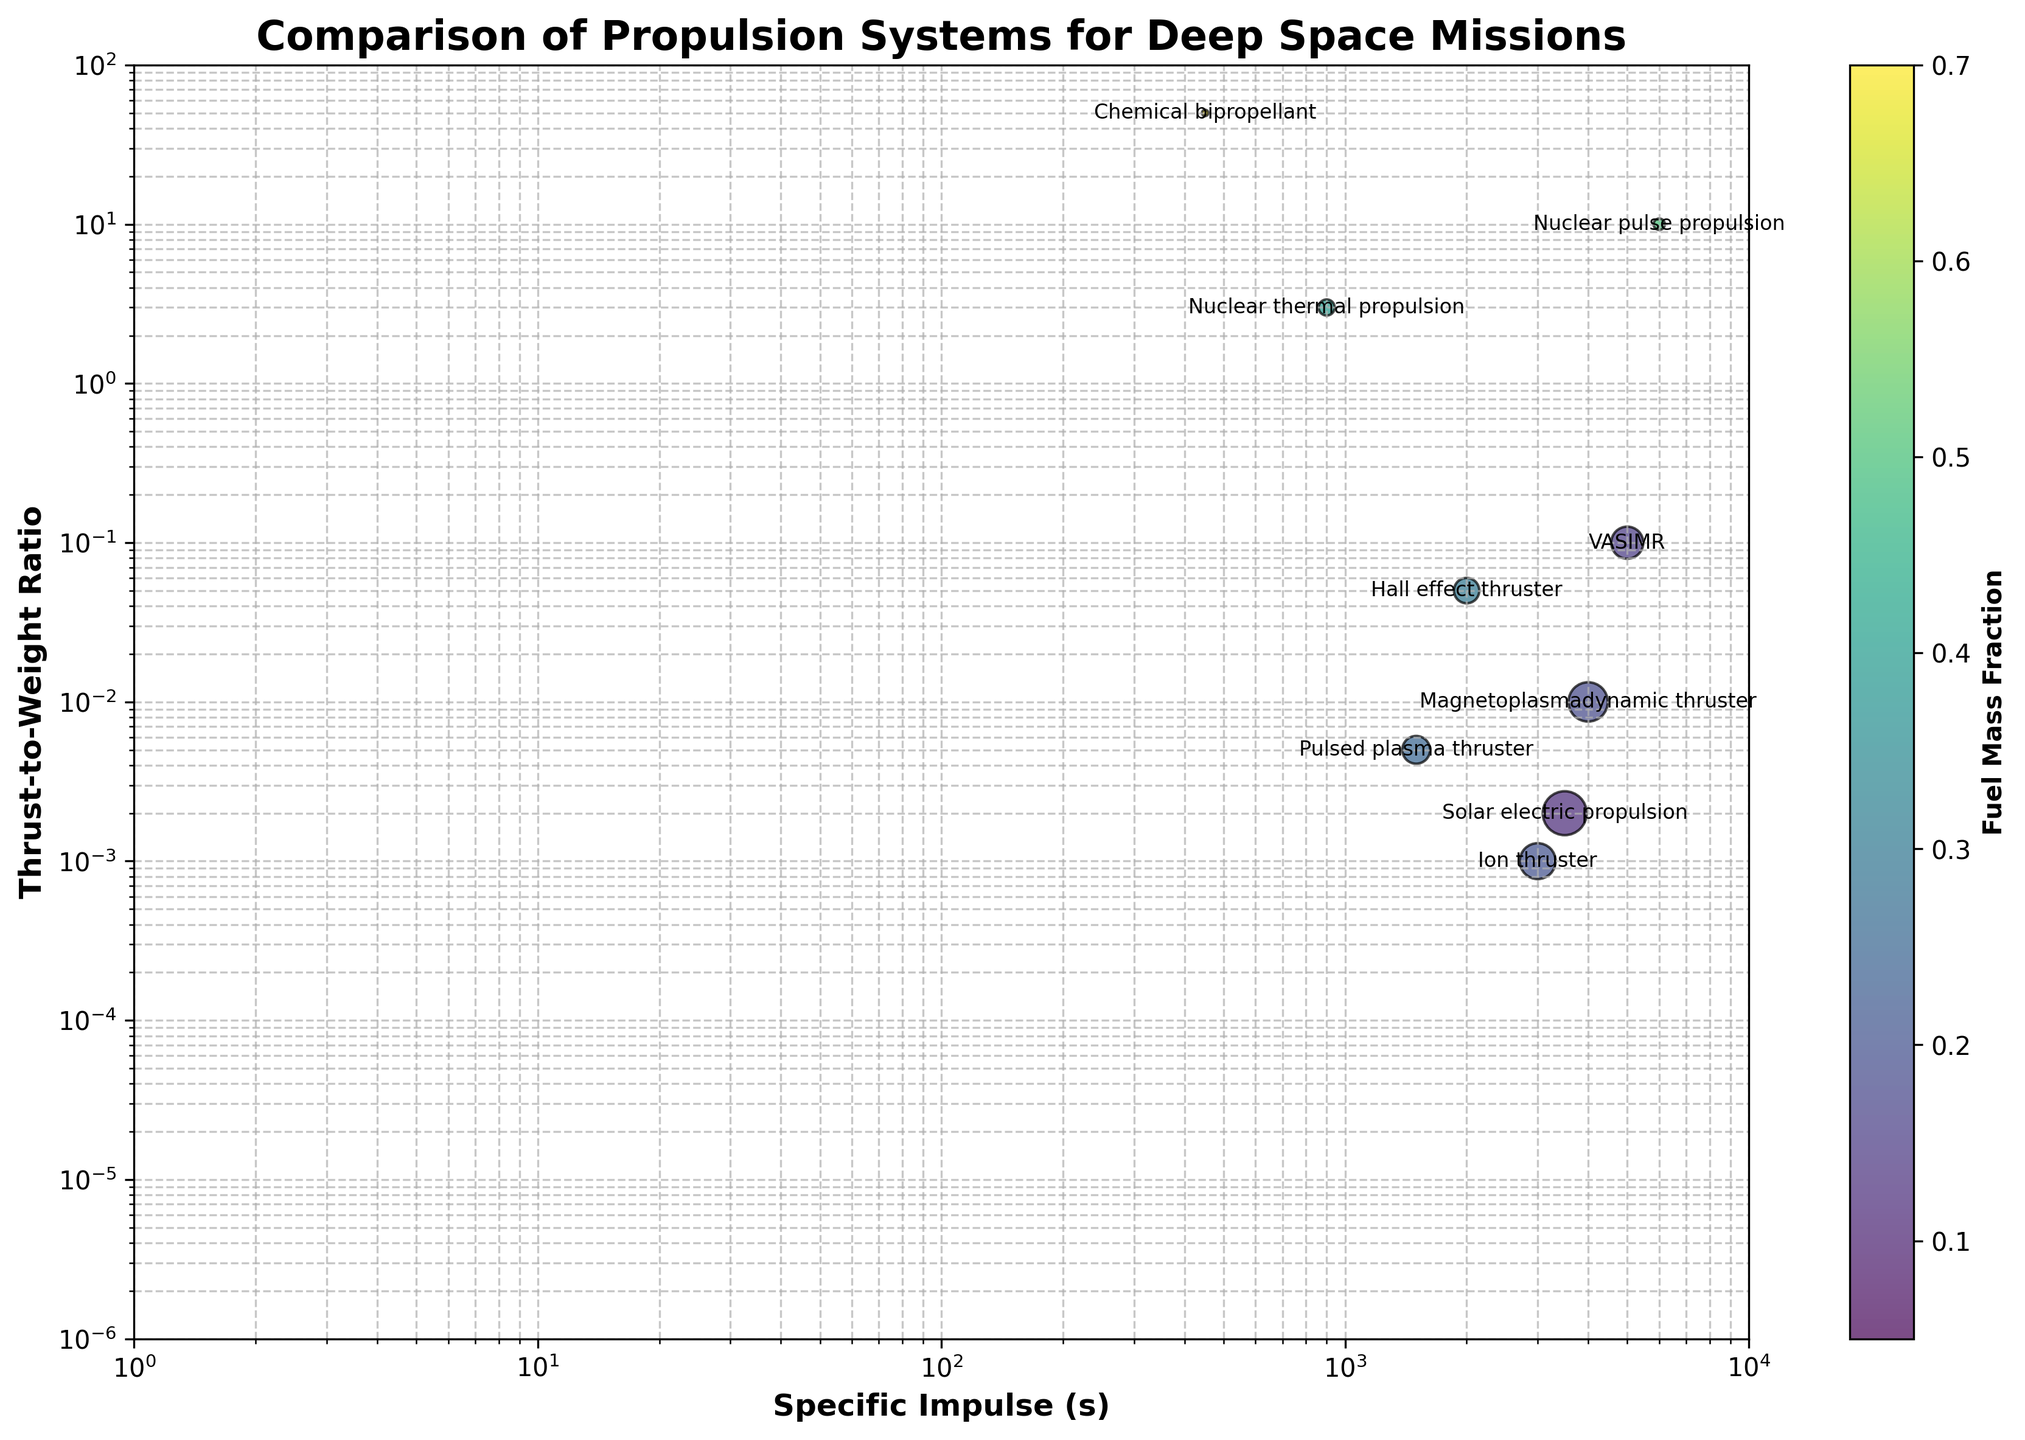What is the title of the figure? The title of the figure is clearly displayed at the top of the plot.
Answer: Comparison of Propulsion Systems for Deep Space Missions What are the labels for the x and y axes? The x and y-axis labels are shown directly on the plot.
Answer: Specific Impulse (s), Thrust-to-Weight Ratio How many propulsion systems are compared in the figure? Each propulsion system is represented by a bubble on the plot, and each one is labeled. By counting these labels, we can determine the number.
Answer: 10 Which propulsion system has the highest specific impulse? By looking at the x-axis values, we find the bubble farthest to the right, then check the corresponding propulsion system label.
Answer: Nuclear pulse propulsion Which propulsion system has the lowest thrust-to-weight ratio? By looking at the y-axis values, we find the bubble closest to the bottom, then check the corresponding propulsion system label.
Answer: Solar sail Which propulsion system is closest to having a fuel mass fraction of 0.3? The color bar indicates the fuel mass fraction value, so find the bubble nearest to the color representing 0.3 and check the label.
Answer: Hall effect thruster How does the thrust-to-weight ratio of Ion thruster compare to Solar electric propulsion? Locate the bubbles for Ion thruster and Solar electric propulsion along the y-axis, then compare their positions.
Answer: Solar electric propulsion has a higher thrust-to-weight ratio than Ion thruster What can you infer about the mission duration of Nuclear thermal propulsion compared to VASIMR? Looking at the size of the bubbles representing Nuclear thermal propulsion and VASIMR, since bubble size indicates mission duration, compare their sizes.
Answer: Nuclear thermal propulsion has a shorter mission duration than VASIMR Which propulsion system has the smallest fuel mass fraction? Observe the color of the bubbles, find the one closest to the darkest color (representing the smallest fuel mass fraction), then check its label.
Answer: Solar sail Is there a general trend between specific impulse and thrust-to-weight ratio? By looking at the overall distribution of bubbles, assess whether there is any apparent trend between the x and y positions of the bubbles.
Answer: Higher specific impulse often corresponds to lower thrust-to-weight ratio 